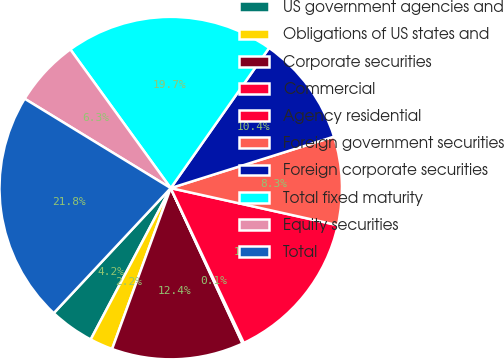Convert chart. <chart><loc_0><loc_0><loc_500><loc_500><pie_chart><fcel>US government agencies and<fcel>Obligations of US states and<fcel>Corporate securities<fcel>Commercial<fcel>Agency residential<fcel>Foreign government securities<fcel>Foreign corporate securities<fcel>Total fixed maturity<fcel>Equity securities<fcel>Total<nl><fcel>4.23%<fcel>2.18%<fcel>12.45%<fcel>0.13%<fcel>14.5%<fcel>8.34%<fcel>10.4%<fcel>19.71%<fcel>6.29%<fcel>21.77%<nl></chart> 